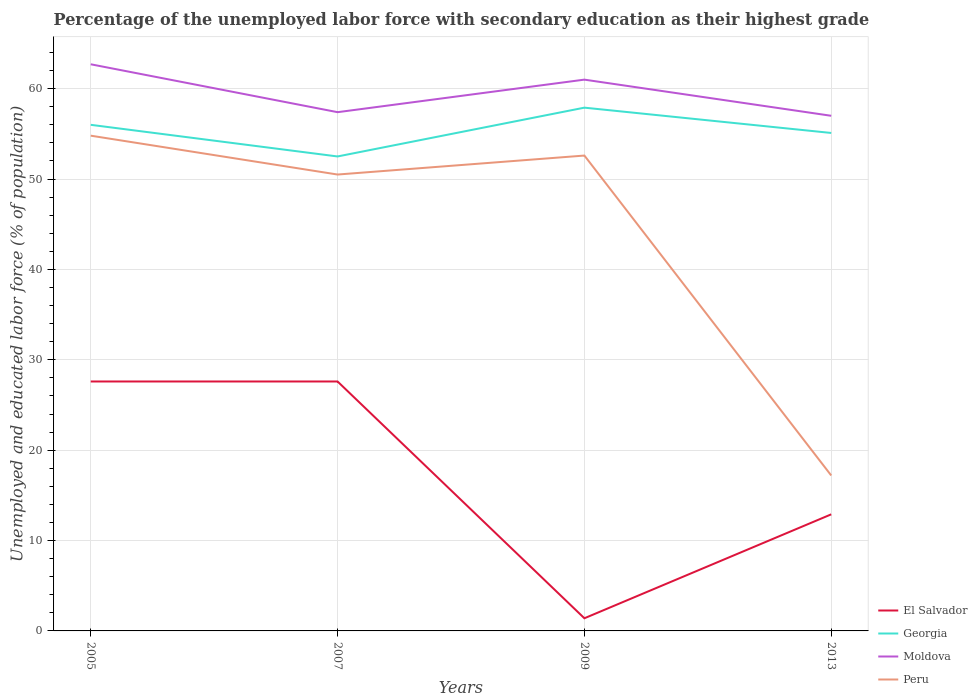Is the number of lines equal to the number of legend labels?
Provide a succinct answer. Yes. Across all years, what is the maximum percentage of the unemployed labor force with secondary education in El Salvador?
Ensure brevity in your answer.  1.4. In which year was the percentage of the unemployed labor force with secondary education in Peru maximum?
Offer a terse response. 2013. What is the total percentage of the unemployed labor force with secondary education in Georgia in the graph?
Your answer should be very brief. 0.9. What is the difference between the highest and the second highest percentage of the unemployed labor force with secondary education in Peru?
Make the answer very short. 37.6. What is the difference between the highest and the lowest percentage of the unemployed labor force with secondary education in Peru?
Provide a succinct answer. 3. What is the difference between two consecutive major ticks on the Y-axis?
Provide a short and direct response. 10. Does the graph contain grids?
Give a very brief answer. Yes. What is the title of the graph?
Offer a terse response. Percentage of the unemployed labor force with secondary education as their highest grade. Does "Sudan" appear as one of the legend labels in the graph?
Your answer should be very brief. No. What is the label or title of the X-axis?
Your answer should be compact. Years. What is the label or title of the Y-axis?
Keep it short and to the point. Unemployed and educated labor force (% of population). What is the Unemployed and educated labor force (% of population) of El Salvador in 2005?
Offer a very short reply. 27.6. What is the Unemployed and educated labor force (% of population) in Georgia in 2005?
Your answer should be very brief. 56. What is the Unemployed and educated labor force (% of population) in Moldova in 2005?
Your answer should be compact. 62.7. What is the Unemployed and educated labor force (% of population) in Peru in 2005?
Your answer should be very brief. 54.8. What is the Unemployed and educated labor force (% of population) in El Salvador in 2007?
Offer a terse response. 27.6. What is the Unemployed and educated labor force (% of population) in Georgia in 2007?
Your response must be concise. 52.5. What is the Unemployed and educated labor force (% of population) in Moldova in 2007?
Provide a short and direct response. 57.4. What is the Unemployed and educated labor force (% of population) in Peru in 2007?
Your response must be concise. 50.5. What is the Unemployed and educated labor force (% of population) in El Salvador in 2009?
Make the answer very short. 1.4. What is the Unemployed and educated labor force (% of population) of Georgia in 2009?
Provide a short and direct response. 57.9. What is the Unemployed and educated labor force (% of population) of Peru in 2009?
Give a very brief answer. 52.6. What is the Unemployed and educated labor force (% of population) in El Salvador in 2013?
Provide a succinct answer. 12.9. What is the Unemployed and educated labor force (% of population) of Georgia in 2013?
Ensure brevity in your answer.  55.1. What is the Unemployed and educated labor force (% of population) in Peru in 2013?
Offer a very short reply. 17.2. Across all years, what is the maximum Unemployed and educated labor force (% of population) of El Salvador?
Provide a succinct answer. 27.6. Across all years, what is the maximum Unemployed and educated labor force (% of population) of Georgia?
Keep it short and to the point. 57.9. Across all years, what is the maximum Unemployed and educated labor force (% of population) of Moldova?
Provide a succinct answer. 62.7. Across all years, what is the maximum Unemployed and educated labor force (% of population) in Peru?
Your response must be concise. 54.8. Across all years, what is the minimum Unemployed and educated labor force (% of population) in El Salvador?
Make the answer very short. 1.4. Across all years, what is the minimum Unemployed and educated labor force (% of population) in Georgia?
Make the answer very short. 52.5. Across all years, what is the minimum Unemployed and educated labor force (% of population) of Peru?
Provide a succinct answer. 17.2. What is the total Unemployed and educated labor force (% of population) in El Salvador in the graph?
Make the answer very short. 69.5. What is the total Unemployed and educated labor force (% of population) of Georgia in the graph?
Your answer should be very brief. 221.5. What is the total Unemployed and educated labor force (% of population) in Moldova in the graph?
Your answer should be very brief. 238.1. What is the total Unemployed and educated labor force (% of population) in Peru in the graph?
Provide a short and direct response. 175.1. What is the difference between the Unemployed and educated labor force (% of population) in El Salvador in 2005 and that in 2007?
Offer a terse response. 0. What is the difference between the Unemployed and educated labor force (% of population) in Georgia in 2005 and that in 2007?
Ensure brevity in your answer.  3.5. What is the difference between the Unemployed and educated labor force (% of population) in Peru in 2005 and that in 2007?
Your response must be concise. 4.3. What is the difference between the Unemployed and educated labor force (% of population) in El Salvador in 2005 and that in 2009?
Keep it short and to the point. 26.2. What is the difference between the Unemployed and educated labor force (% of population) in Moldova in 2005 and that in 2009?
Your answer should be compact. 1.7. What is the difference between the Unemployed and educated labor force (% of population) in Peru in 2005 and that in 2013?
Your response must be concise. 37.6. What is the difference between the Unemployed and educated labor force (% of population) of El Salvador in 2007 and that in 2009?
Offer a terse response. 26.2. What is the difference between the Unemployed and educated labor force (% of population) in Georgia in 2007 and that in 2009?
Provide a succinct answer. -5.4. What is the difference between the Unemployed and educated labor force (% of population) in Peru in 2007 and that in 2009?
Provide a short and direct response. -2.1. What is the difference between the Unemployed and educated labor force (% of population) of El Salvador in 2007 and that in 2013?
Your answer should be compact. 14.7. What is the difference between the Unemployed and educated labor force (% of population) in Georgia in 2007 and that in 2013?
Your answer should be compact. -2.6. What is the difference between the Unemployed and educated labor force (% of population) of Peru in 2007 and that in 2013?
Keep it short and to the point. 33.3. What is the difference between the Unemployed and educated labor force (% of population) of Georgia in 2009 and that in 2013?
Provide a succinct answer. 2.8. What is the difference between the Unemployed and educated labor force (% of population) in Moldova in 2009 and that in 2013?
Offer a very short reply. 4. What is the difference between the Unemployed and educated labor force (% of population) of Peru in 2009 and that in 2013?
Your answer should be very brief. 35.4. What is the difference between the Unemployed and educated labor force (% of population) in El Salvador in 2005 and the Unemployed and educated labor force (% of population) in Georgia in 2007?
Keep it short and to the point. -24.9. What is the difference between the Unemployed and educated labor force (% of population) in El Salvador in 2005 and the Unemployed and educated labor force (% of population) in Moldova in 2007?
Your response must be concise. -29.8. What is the difference between the Unemployed and educated labor force (% of population) in El Salvador in 2005 and the Unemployed and educated labor force (% of population) in Peru in 2007?
Your answer should be very brief. -22.9. What is the difference between the Unemployed and educated labor force (% of population) in Moldova in 2005 and the Unemployed and educated labor force (% of population) in Peru in 2007?
Your answer should be very brief. 12.2. What is the difference between the Unemployed and educated labor force (% of population) in El Salvador in 2005 and the Unemployed and educated labor force (% of population) in Georgia in 2009?
Make the answer very short. -30.3. What is the difference between the Unemployed and educated labor force (% of population) in El Salvador in 2005 and the Unemployed and educated labor force (% of population) in Moldova in 2009?
Keep it short and to the point. -33.4. What is the difference between the Unemployed and educated labor force (% of population) in El Salvador in 2005 and the Unemployed and educated labor force (% of population) in Peru in 2009?
Provide a short and direct response. -25. What is the difference between the Unemployed and educated labor force (% of population) of El Salvador in 2005 and the Unemployed and educated labor force (% of population) of Georgia in 2013?
Provide a succinct answer. -27.5. What is the difference between the Unemployed and educated labor force (% of population) of El Salvador in 2005 and the Unemployed and educated labor force (% of population) of Moldova in 2013?
Give a very brief answer. -29.4. What is the difference between the Unemployed and educated labor force (% of population) of Georgia in 2005 and the Unemployed and educated labor force (% of population) of Peru in 2013?
Offer a very short reply. 38.8. What is the difference between the Unemployed and educated labor force (% of population) of Moldova in 2005 and the Unemployed and educated labor force (% of population) of Peru in 2013?
Ensure brevity in your answer.  45.5. What is the difference between the Unemployed and educated labor force (% of population) in El Salvador in 2007 and the Unemployed and educated labor force (% of population) in Georgia in 2009?
Make the answer very short. -30.3. What is the difference between the Unemployed and educated labor force (% of population) of El Salvador in 2007 and the Unemployed and educated labor force (% of population) of Moldova in 2009?
Your answer should be compact. -33.4. What is the difference between the Unemployed and educated labor force (% of population) in El Salvador in 2007 and the Unemployed and educated labor force (% of population) in Georgia in 2013?
Provide a succinct answer. -27.5. What is the difference between the Unemployed and educated labor force (% of population) of El Salvador in 2007 and the Unemployed and educated labor force (% of population) of Moldova in 2013?
Keep it short and to the point. -29.4. What is the difference between the Unemployed and educated labor force (% of population) in El Salvador in 2007 and the Unemployed and educated labor force (% of population) in Peru in 2013?
Offer a terse response. 10.4. What is the difference between the Unemployed and educated labor force (% of population) of Georgia in 2007 and the Unemployed and educated labor force (% of population) of Peru in 2013?
Offer a terse response. 35.3. What is the difference between the Unemployed and educated labor force (% of population) of Moldova in 2007 and the Unemployed and educated labor force (% of population) of Peru in 2013?
Provide a succinct answer. 40.2. What is the difference between the Unemployed and educated labor force (% of population) of El Salvador in 2009 and the Unemployed and educated labor force (% of population) of Georgia in 2013?
Offer a terse response. -53.7. What is the difference between the Unemployed and educated labor force (% of population) of El Salvador in 2009 and the Unemployed and educated labor force (% of population) of Moldova in 2013?
Make the answer very short. -55.6. What is the difference between the Unemployed and educated labor force (% of population) of El Salvador in 2009 and the Unemployed and educated labor force (% of population) of Peru in 2013?
Provide a short and direct response. -15.8. What is the difference between the Unemployed and educated labor force (% of population) in Georgia in 2009 and the Unemployed and educated labor force (% of population) in Moldova in 2013?
Offer a terse response. 0.9. What is the difference between the Unemployed and educated labor force (% of population) in Georgia in 2009 and the Unemployed and educated labor force (% of population) in Peru in 2013?
Offer a very short reply. 40.7. What is the difference between the Unemployed and educated labor force (% of population) in Moldova in 2009 and the Unemployed and educated labor force (% of population) in Peru in 2013?
Your response must be concise. 43.8. What is the average Unemployed and educated labor force (% of population) in El Salvador per year?
Make the answer very short. 17.38. What is the average Unemployed and educated labor force (% of population) in Georgia per year?
Your answer should be very brief. 55.38. What is the average Unemployed and educated labor force (% of population) in Moldova per year?
Provide a succinct answer. 59.52. What is the average Unemployed and educated labor force (% of population) of Peru per year?
Your answer should be compact. 43.77. In the year 2005, what is the difference between the Unemployed and educated labor force (% of population) in El Salvador and Unemployed and educated labor force (% of population) in Georgia?
Your answer should be very brief. -28.4. In the year 2005, what is the difference between the Unemployed and educated labor force (% of population) of El Salvador and Unemployed and educated labor force (% of population) of Moldova?
Your response must be concise. -35.1. In the year 2005, what is the difference between the Unemployed and educated labor force (% of population) of El Salvador and Unemployed and educated labor force (% of population) of Peru?
Your response must be concise. -27.2. In the year 2005, what is the difference between the Unemployed and educated labor force (% of population) of Georgia and Unemployed and educated labor force (% of population) of Moldova?
Your answer should be compact. -6.7. In the year 2005, what is the difference between the Unemployed and educated labor force (% of population) of Moldova and Unemployed and educated labor force (% of population) of Peru?
Offer a terse response. 7.9. In the year 2007, what is the difference between the Unemployed and educated labor force (% of population) in El Salvador and Unemployed and educated labor force (% of population) in Georgia?
Provide a succinct answer. -24.9. In the year 2007, what is the difference between the Unemployed and educated labor force (% of population) of El Salvador and Unemployed and educated labor force (% of population) of Moldova?
Offer a very short reply. -29.8. In the year 2007, what is the difference between the Unemployed and educated labor force (% of population) of El Salvador and Unemployed and educated labor force (% of population) of Peru?
Keep it short and to the point. -22.9. In the year 2007, what is the difference between the Unemployed and educated labor force (% of population) of Georgia and Unemployed and educated labor force (% of population) of Moldova?
Make the answer very short. -4.9. In the year 2007, what is the difference between the Unemployed and educated labor force (% of population) in Moldova and Unemployed and educated labor force (% of population) in Peru?
Your answer should be very brief. 6.9. In the year 2009, what is the difference between the Unemployed and educated labor force (% of population) of El Salvador and Unemployed and educated labor force (% of population) of Georgia?
Provide a short and direct response. -56.5. In the year 2009, what is the difference between the Unemployed and educated labor force (% of population) in El Salvador and Unemployed and educated labor force (% of population) in Moldova?
Provide a short and direct response. -59.6. In the year 2009, what is the difference between the Unemployed and educated labor force (% of population) in El Salvador and Unemployed and educated labor force (% of population) in Peru?
Ensure brevity in your answer.  -51.2. In the year 2009, what is the difference between the Unemployed and educated labor force (% of population) of Georgia and Unemployed and educated labor force (% of population) of Peru?
Provide a short and direct response. 5.3. In the year 2013, what is the difference between the Unemployed and educated labor force (% of population) in El Salvador and Unemployed and educated labor force (% of population) in Georgia?
Your answer should be very brief. -42.2. In the year 2013, what is the difference between the Unemployed and educated labor force (% of population) in El Salvador and Unemployed and educated labor force (% of population) in Moldova?
Provide a short and direct response. -44.1. In the year 2013, what is the difference between the Unemployed and educated labor force (% of population) in El Salvador and Unemployed and educated labor force (% of population) in Peru?
Offer a terse response. -4.3. In the year 2013, what is the difference between the Unemployed and educated labor force (% of population) of Georgia and Unemployed and educated labor force (% of population) of Peru?
Offer a very short reply. 37.9. In the year 2013, what is the difference between the Unemployed and educated labor force (% of population) of Moldova and Unemployed and educated labor force (% of population) of Peru?
Provide a succinct answer. 39.8. What is the ratio of the Unemployed and educated labor force (% of population) of El Salvador in 2005 to that in 2007?
Your answer should be compact. 1. What is the ratio of the Unemployed and educated labor force (% of population) of Georgia in 2005 to that in 2007?
Your response must be concise. 1.07. What is the ratio of the Unemployed and educated labor force (% of population) in Moldova in 2005 to that in 2007?
Your answer should be very brief. 1.09. What is the ratio of the Unemployed and educated labor force (% of population) of Peru in 2005 to that in 2007?
Ensure brevity in your answer.  1.09. What is the ratio of the Unemployed and educated labor force (% of population) of El Salvador in 2005 to that in 2009?
Offer a terse response. 19.71. What is the ratio of the Unemployed and educated labor force (% of population) of Georgia in 2005 to that in 2009?
Make the answer very short. 0.97. What is the ratio of the Unemployed and educated labor force (% of population) in Moldova in 2005 to that in 2009?
Provide a succinct answer. 1.03. What is the ratio of the Unemployed and educated labor force (% of population) in Peru in 2005 to that in 2009?
Ensure brevity in your answer.  1.04. What is the ratio of the Unemployed and educated labor force (% of population) in El Salvador in 2005 to that in 2013?
Your response must be concise. 2.14. What is the ratio of the Unemployed and educated labor force (% of population) in Georgia in 2005 to that in 2013?
Your answer should be compact. 1.02. What is the ratio of the Unemployed and educated labor force (% of population) in Peru in 2005 to that in 2013?
Offer a terse response. 3.19. What is the ratio of the Unemployed and educated labor force (% of population) of El Salvador in 2007 to that in 2009?
Offer a terse response. 19.71. What is the ratio of the Unemployed and educated labor force (% of population) in Georgia in 2007 to that in 2009?
Provide a succinct answer. 0.91. What is the ratio of the Unemployed and educated labor force (% of population) in Moldova in 2007 to that in 2009?
Make the answer very short. 0.94. What is the ratio of the Unemployed and educated labor force (% of population) of Peru in 2007 to that in 2009?
Offer a terse response. 0.96. What is the ratio of the Unemployed and educated labor force (% of population) in El Salvador in 2007 to that in 2013?
Offer a terse response. 2.14. What is the ratio of the Unemployed and educated labor force (% of population) of Georgia in 2007 to that in 2013?
Your answer should be very brief. 0.95. What is the ratio of the Unemployed and educated labor force (% of population) in Peru in 2007 to that in 2013?
Offer a terse response. 2.94. What is the ratio of the Unemployed and educated labor force (% of population) in El Salvador in 2009 to that in 2013?
Make the answer very short. 0.11. What is the ratio of the Unemployed and educated labor force (% of population) of Georgia in 2009 to that in 2013?
Offer a terse response. 1.05. What is the ratio of the Unemployed and educated labor force (% of population) of Moldova in 2009 to that in 2013?
Your answer should be compact. 1.07. What is the ratio of the Unemployed and educated labor force (% of population) of Peru in 2009 to that in 2013?
Your answer should be very brief. 3.06. What is the difference between the highest and the second highest Unemployed and educated labor force (% of population) in El Salvador?
Your response must be concise. 0. What is the difference between the highest and the second highest Unemployed and educated labor force (% of population) in Peru?
Your answer should be very brief. 2.2. What is the difference between the highest and the lowest Unemployed and educated labor force (% of population) in El Salvador?
Offer a very short reply. 26.2. What is the difference between the highest and the lowest Unemployed and educated labor force (% of population) in Georgia?
Offer a very short reply. 5.4. What is the difference between the highest and the lowest Unemployed and educated labor force (% of population) of Peru?
Offer a very short reply. 37.6. 